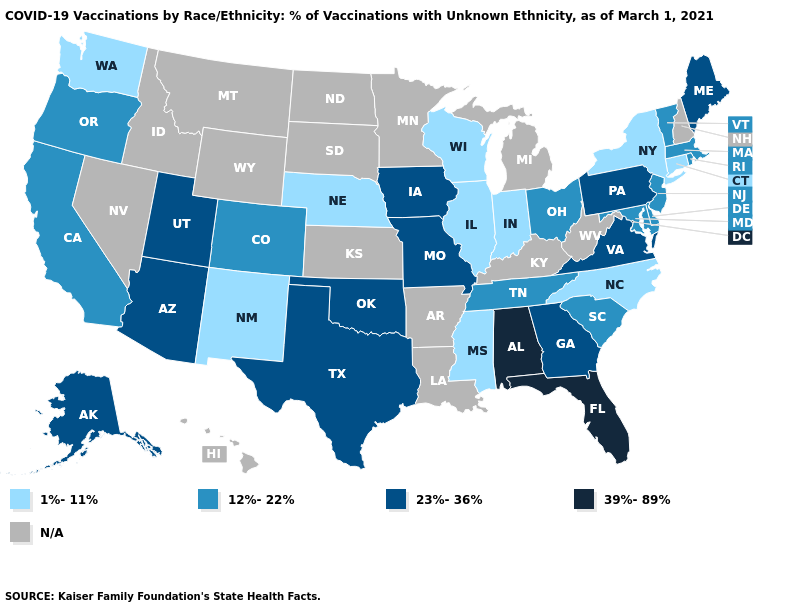Does Colorado have the highest value in the West?
Keep it brief. No. Name the states that have a value in the range 1%-11%?
Quick response, please. Connecticut, Illinois, Indiana, Mississippi, Nebraska, New Mexico, New York, North Carolina, Washington, Wisconsin. Does Illinois have the lowest value in the USA?
Quick response, please. Yes. Does Rhode Island have the lowest value in the Northeast?
Quick response, please. No. Which states have the highest value in the USA?
Write a very short answer. Alabama, Florida. Name the states that have a value in the range 1%-11%?
Quick response, please. Connecticut, Illinois, Indiana, Mississippi, Nebraska, New Mexico, New York, North Carolina, Washington, Wisconsin. Name the states that have a value in the range 12%-22%?
Answer briefly. California, Colorado, Delaware, Maryland, Massachusetts, New Jersey, Ohio, Oregon, Rhode Island, South Carolina, Tennessee, Vermont. What is the lowest value in states that border Virginia?
Concise answer only. 1%-11%. Which states have the highest value in the USA?
Give a very brief answer. Alabama, Florida. What is the value of Iowa?
Answer briefly. 23%-36%. Name the states that have a value in the range 1%-11%?
Write a very short answer. Connecticut, Illinois, Indiana, Mississippi, Nebraska, New Mexico, New York, North Carolina, Washington, Wisconsin. Name the states that have a value in the range 39%-89%?
Be succinct. Alabama, Florida. What is the lowest value in the Northeast?
Short answer required. 1%-11%. Name the states that have a value in the range 23%-36%?
Be succinct. Alaska, Arizona, Georgia, Iowa, Maine, Missouri, Oklahoma, Pennsylvania, Texas, Utah, Virginia. Which states have the highest value in the USA?
Short answer required. Alabama, Florida. 